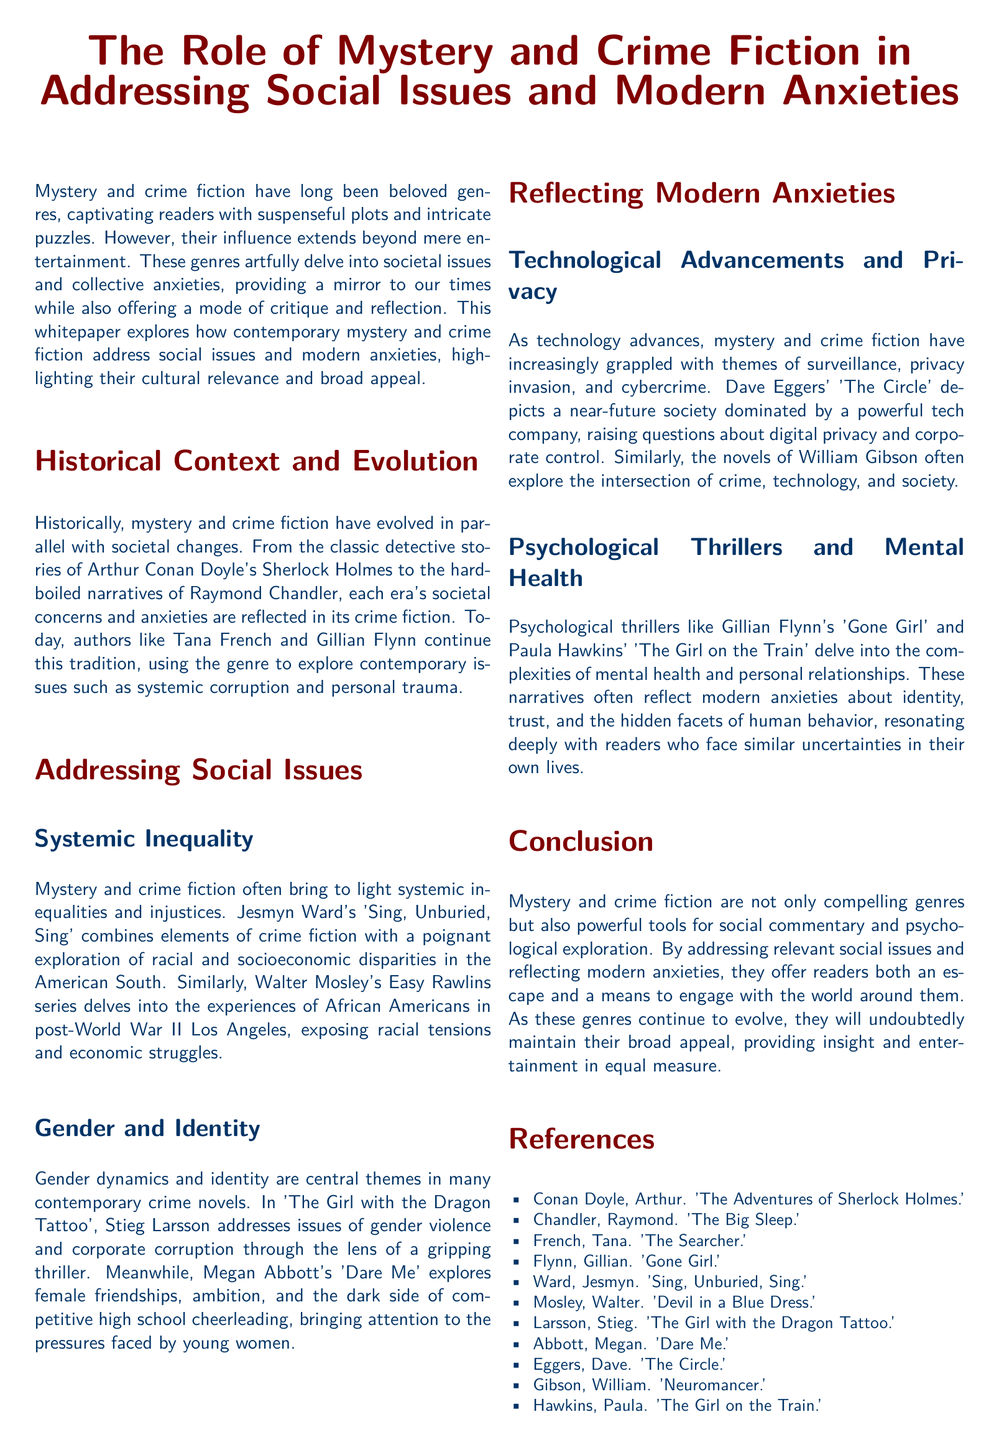What are the two main themes addressed in many contemporary crime novels? The two main themes are gender dynamics and identity.
Answer: gender dynamics and identity Name an author mentioned who explores systemic inequality in their work. Jesmyn Ward is mentioned as exploring systemic inequality in their work.
Answer: Jesmyn Ward What is the title of Dave Eggers' book that discusses digital privacy? The title of Dave Eggers' book is 'The Circle.'
Answer: The Circle Which psychological thriller by Gillian Flynn is mentioned in the document? The psychological thriller by Gillian Flynn is 'Gone Girl.'
Answer: Gone Girl What genre is identified as a powerful tool for social commentary? Mystery and crime fiction is identified as a powerful tool for social commentary.
Answer: Mystery and crime fiction Which detective character is referenced in the historical context of the genre? The detective character referenced is Sherlock Holmes.
Answer: Sherlock Holmes What societal issue does Walter Mosley's Easy Rawlins series primarily address? The series primarily addresses racial tensions and economic struggles.
Answer: racial tensions and economic struggles Name one modern anxiety theme that mystery and crime fiction grapples with. One modern anxiety theme is surveillance.
Answer: surveillance Which author's work explores the dark side of competitive high school cheerleading? Megan Abbott's work explores the dark side of competitive high school cheerleading.
Answer: Megan Abbott 